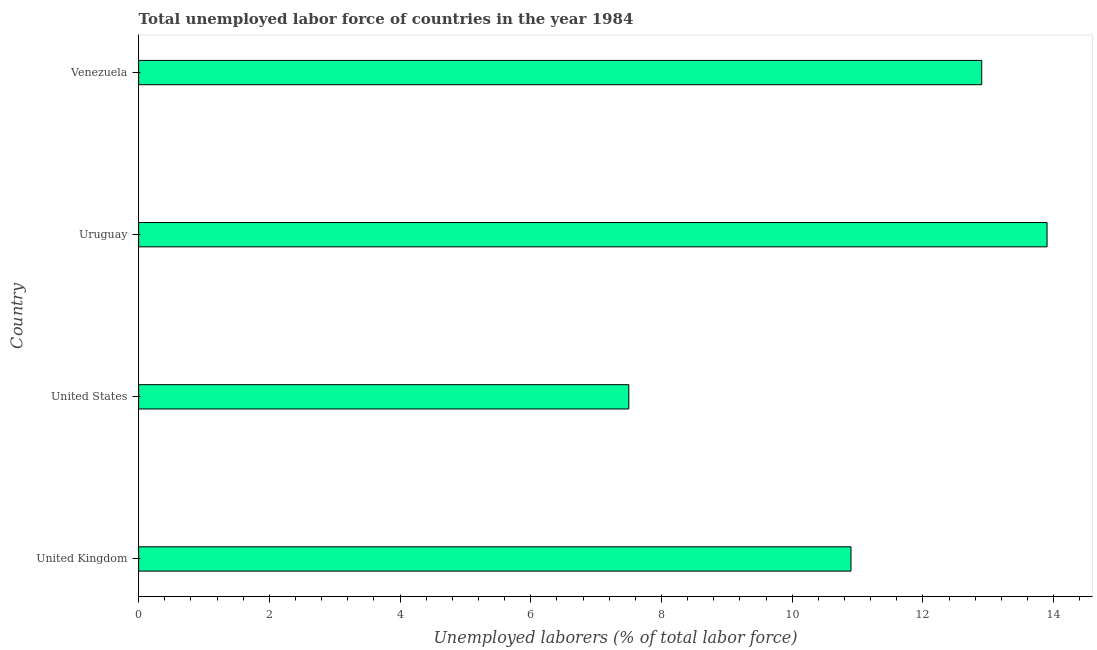Does the graph contain grids?
Your answer should be very brief. No. What is the title of the graph?
Offer a terse response. Total unemployed labor force of countries in the year 1984. What is the label or title of the X-axis?
Offer a very short reply. Unemployed laborers (% of total labor force). What is the label or title of the Y-axis?
Your answer should be compact. Country. What is the total unemployed labour force in Venezuela?
Offer a terse response. 12.9. Across all countries, what is the maximum total unemployed labour force?
Keep it short and to the point. 13.9. In which country was the total unemployed labour force maximum?
Provide a short and direct response. Uruguay. What is the sum of the total unemployed labour force?
Your response must be concise. 45.2. What is the difference between the total unemployed labour force in Uruguay and Venezuela?
Your answer should be compact. 1. What is the average total unemployed labour force per country?
Your answer should be very brief. 11.3. What is the median total unemployed labour force?
Your answer should be very brief. 11.9. In how many countries, is the total unemployed labour force greater than 8.8 %?
Your answer should be very brief. 3. What is the ratio of the total unemployed labour force in United Kingdom to that in Uruguay?
Give a very brief answer. 0.78. Is the total unemployed labour force in United Kingdom less than that in Venezuela?
Your answer should be compact. Yes. Is the difference between the total unemployed labour force in Uruguay and Venezuela greater than the difference between any two countries?
Provide a short and direct response. No. What is the difference between the highest and the second highest total unemployed labour force?
Your answer should be compact. 1. Is the sum of the total unemployed labour force in United States and Venezuela greater than the maximum total unemployed labour force across all countries?
Keep it short and to the point. Yes. Are all the bars in the graph horizontal?
Your response must be concise. Yes. How many countries are there in the graph?
Offer a very short reply. 4. What is the difference between two consecutive major ticks on the X-axis?
Keep it short and to the point. 2. Are the values on the major ticks of X-axis written in scientific E-notation?
Keep it short and to the point. No. What is the Unemployed laborers (% of total labor force) of United Kingdom?
Provide a short and direct response. 10.9. What is the Unemployed laborers (% of total labor force) of Uruguay?
Your answer should be compact. 13.9. What is the Unemployed laborers (% of total labor force) in Venezuela?
Give a very brief answer. 12.9. What is the difference between the Unemployed laborers (% of total labor force) in United States and Uruguay?
Provide a succinct answer. -6.4. What is the ratio of the Unemployed laborers (% of total labor force) in United Kingdom to that in United States?
Your response must be concise. 1.45. What is the ratio of the Unemployed laborers (% of total labor force) in United Kingdom to that in Uruguay?
Ensure brevity in your answer.  0.78. What is the ratio of the Unemployed laborers (% of total labor force) in United Kingdom to that in Venezuela?
Offer a very short reply. 0.84. What is the ratio of the Unemployed laborers (% of total labor force) in United States to that in Uruguay?
Offer a very short reply. 0.54. What is the ratio of the Unemployed laborers (% of total labor force) in United States to that in Venezuela?
Your answer should be very brief. 0.58. What is the ratio of the Unemployed laborers (% of total labor force) in Uruguay to that in Venezuela?
Your answer should be very brief. 1.08. 